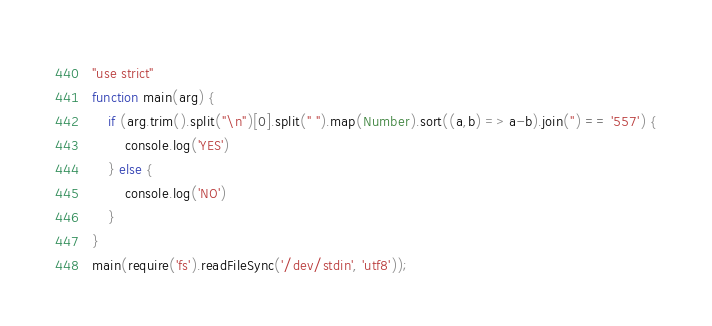<code> <loc_0><loc_0><loc_500><loc_500><_JavaScript_>"use strict"
function main(arg) {
    if (arg.trim().split("\n")[0].split(" ").map(Number).sort((a,b) => a-b).join('') == '557') {
        console.log('YES')
    } else {
        console.log('NO')
    }
}
main(require('fs').readFileSync('/dev/stdin', 'utf8'));</code> 